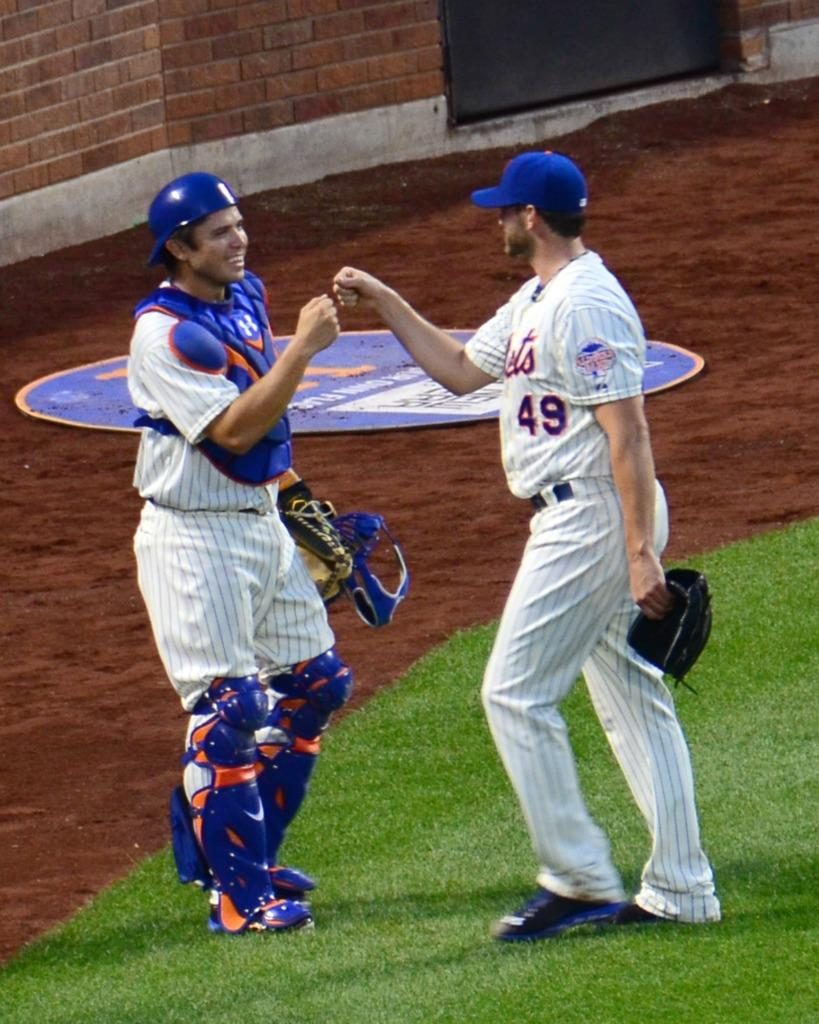<image>
Offer a succinct explanation of the picture presented. a player with a Mets jersey and the number 49 bumping fists with his catcher 